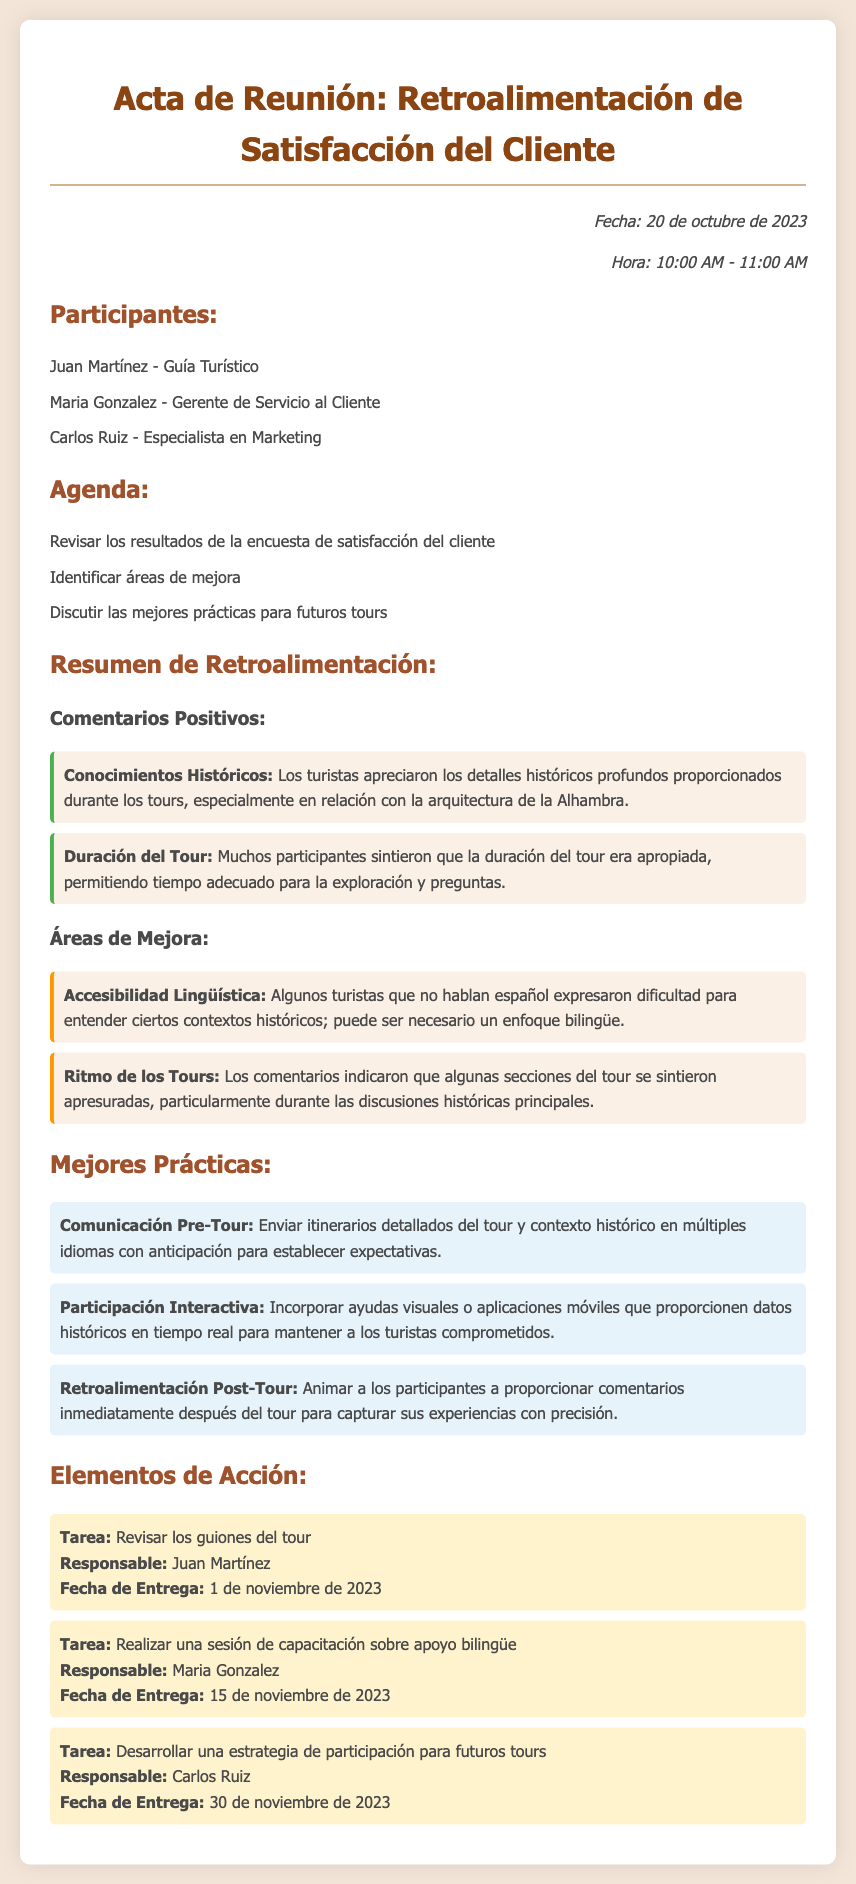¿Cuál es la fecha de la reunión? La fecha de la reunión se menciona en el documento, que es el 20 de octubre de 2023.
Answer: 20 de octubre de 2023 ¿Quién es el responsable de revisar los guiones del tour? El documento indica que Juan Martínez es el responsable de esta tarea.
Answer: Juan Martínez ¿Cuál es una de las áreas de mejora mencionadas? El documento destaca la "Accesibilidad Lingüística" como un área que necesita atención.
Answer: Accesibilidad Lingüística ¿Cuál es una de las mejores prácticas recomendadas para futuros tours? Entre las mejores prácticas, se sugiere "Comunicación Pre-Tour".
Answer: Comunicación Pre-Tour ¿Qué se discutió en la agenda? La agenda incluye "Identificar áreas de mejora" como uno de los puntos a tratar.
Answer: Identificar áreas de mejora ¿Cuál fue un comentario positivo sobre los tours? Un comentario positivo mencionado es sobre los "Conocimientos Históricos" proporcionados.
Answer: Conocimientos Históricos ¿Qué tarea debe completarse antes del 15 de noviembre de 2023? El documento establece que se debe llevar a cabo una "sesión de capacitación sobre apoyo bilingüe" antes de esta fecha.
Answer: sesión de capacitación sobre apoyo bilingüe ¿Cuántos participantes asistieron a la reunión? El número de participantes se menciona en el documento, que son tres.
Answer: Tres ¿En qué horario se llevó a cabo la reunión? El documento especifica que la reunión fue de 10:00 AM a 11:00 AM.
Answer: 10:00 AM - 11:00 AM 